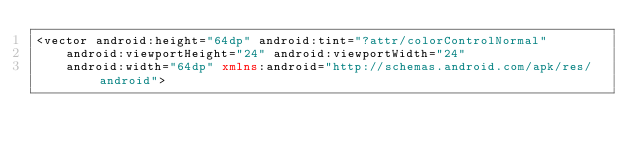<code> <loc_0><loc_0><loc_500><loc_500><_XML_><vector android:height="64dp" android:tint="?attr/colorControlNormal"
    android:viewportHeight="24" android:viewportWidth="24"
    android:width="64dp" xmlns:android="http://schemas.android.com/apk/res/android"></code> 